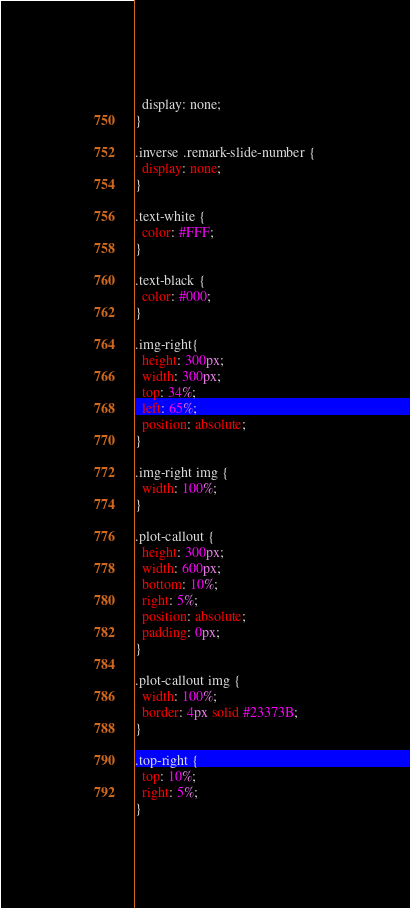Convert code to text. <code><loc_0><loc_0><loc_500><loc_500><_CSS_>  display: none;
}

.inverse .remark-slide-number {
  display: none;
}

.text-white {
  color: #FFF;
}

.text-black {
  color: #000;
}

.img-right{
  height: 300px;
  width: 300px;
  top: 34%;
  left: 65%;
  position: absolute;
}

.img-right img {
  width: 100%;
}

.plot-callout {
  height: 300px;
  width: 600px;
  bottom: 10%;
  right: 5%;
  position: absolute;
  padding: 0px;
}

.plot-callout img {
  width: 100%;
  border: 4px solid #23373B;
}

.top-right {
  top: 10%;
  right: 5%;
}</code> 